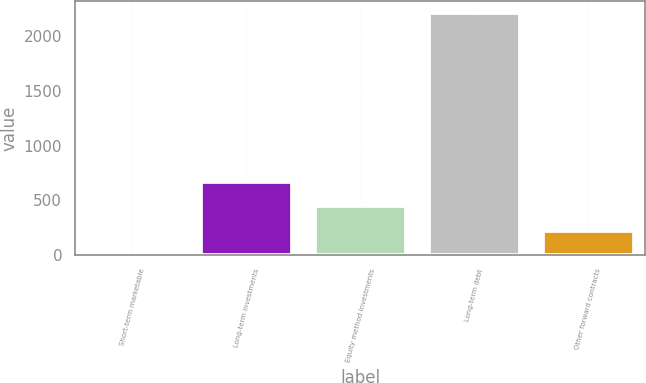Convert chart. <chart><loc_0><loc_0><loc_500><loc_500><bar_chart><fcel>Short-term marketable<fcel>Long-term investments<fcel>Equity method investments<fcel>Long-term debt<fcel>Other forward contracts<nl><fcel>1.4<fcel>665.3<fcel>444<fcel>2214.4<fcel>222.7<nl></chart> 